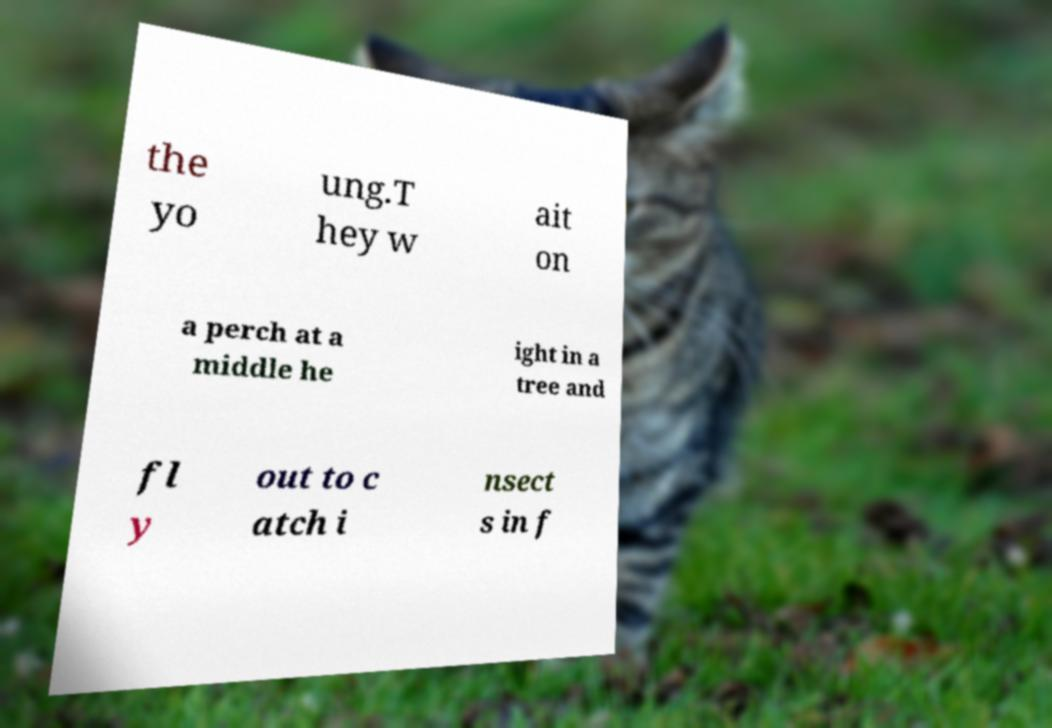Can you accurately transcribe the text from the provided image for me? the yo ung.T hey w ait on a perch at a middle he ight in a tree and fl y out to c atch i nsect s in f 